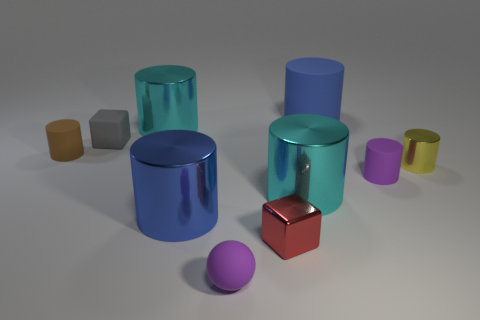Subtract all large blue cylinders. How many cylinders are left? 5 Subtract all purple blocks. Subtract all gray balls. How many blocks are left? 2 Subtract all red balls. How many yellow cylinders are left? 1 Subtract all brown metallic objects. Subtract all small rubber things. How many objects are left? 6 Add 4 blue things. How many blue things are left? 6 Add 3 cyan metallic cylinders. How many cyan metallic cylinders exist? 5 Subtract all red cubes. How many cubes are left? 1 Subtract 0 brown balls. How many objects are left? 10 Subtract all balls. How many objects are left? 9 Subtract 2 blocks. How many blocks are left? 0 